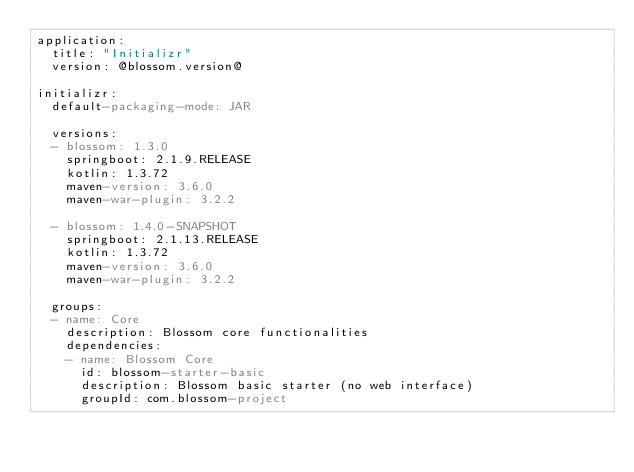<code> <loc_0><loc_0><loc_500><loc_500><_YAML_>application:
  title: "Initializr"
  version: @blossom.version@

initializr:
  default-packaging-mode: JAR

  versions:
  - blossom: 1.3.0
    springboot: 2.1.9.RELEASE
    kotlin: 1.3.72
    maven-version: 3.6.0
    maven-war-plugin: 3.2.2

  - blossom: 1.4.0-SNAPSHOT
    springboot: 2.1.13.RELEASE
    kotlin: 1.3.72
    maven-version: 3.6.0
    maven-war-plugin: 3.2.2

  groups:
  - name: Core
    description: Blossom core functionalities
    dependencies:
    - name: Blossom Core
      id: blossom-starter-basic
      description: Blossom basic starter (no web interface)
      groupId: com.blossom-project</code> 